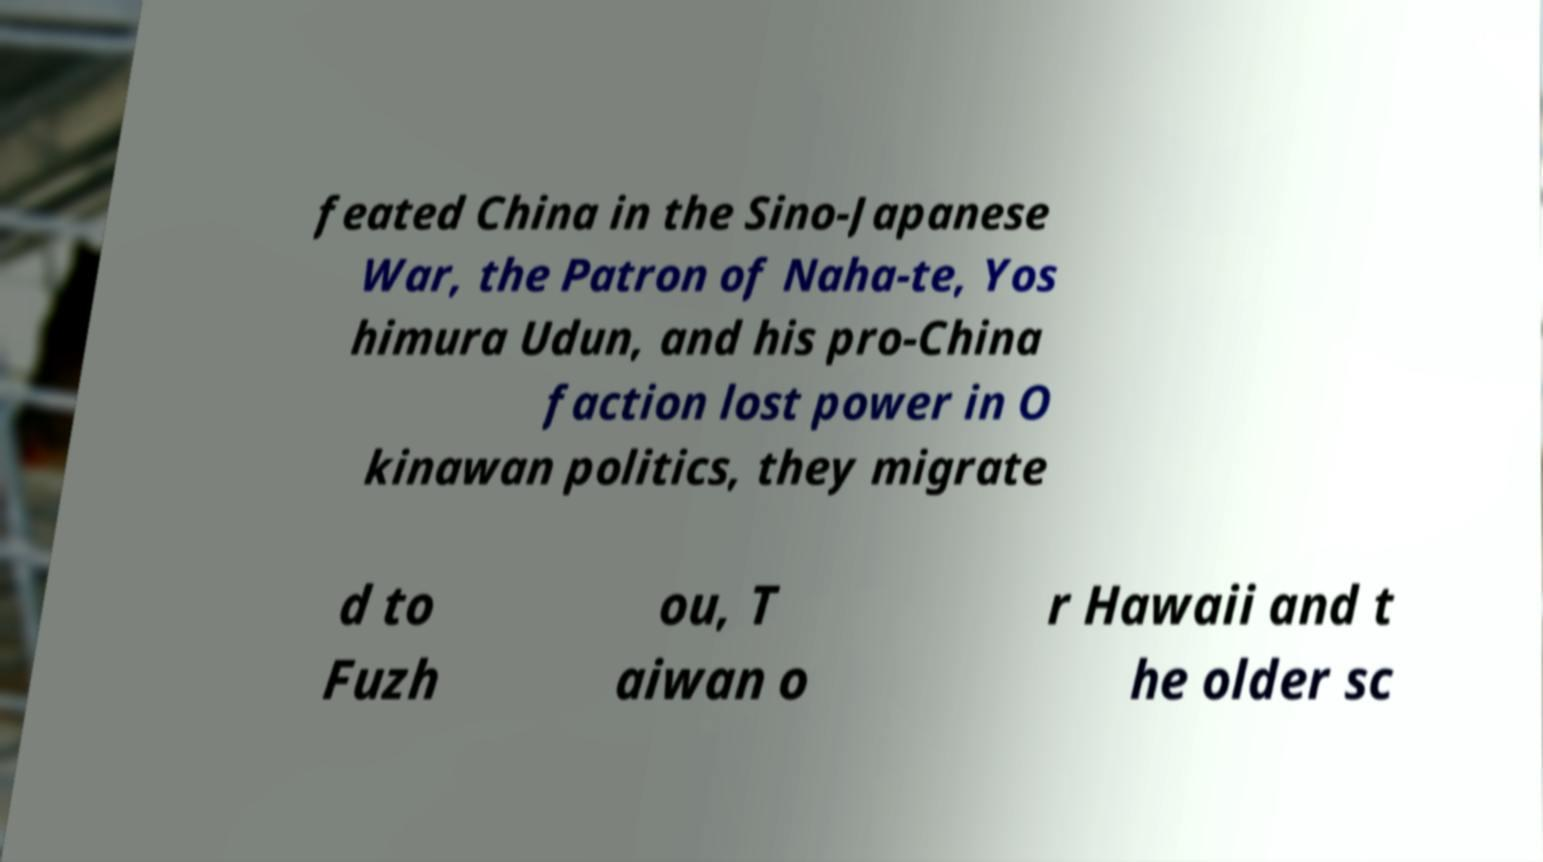There's text embedded in this image that I need extracted. Can you transcribe it verbatim? feated China in the Sino-Japanese War, the Patron of Naha-te, Yos himura Udun, and his pro-China faction lost power in O kinawan politics, they migrate d to Fuzh ou, T aiwan o r Hawaii and t he older sc 